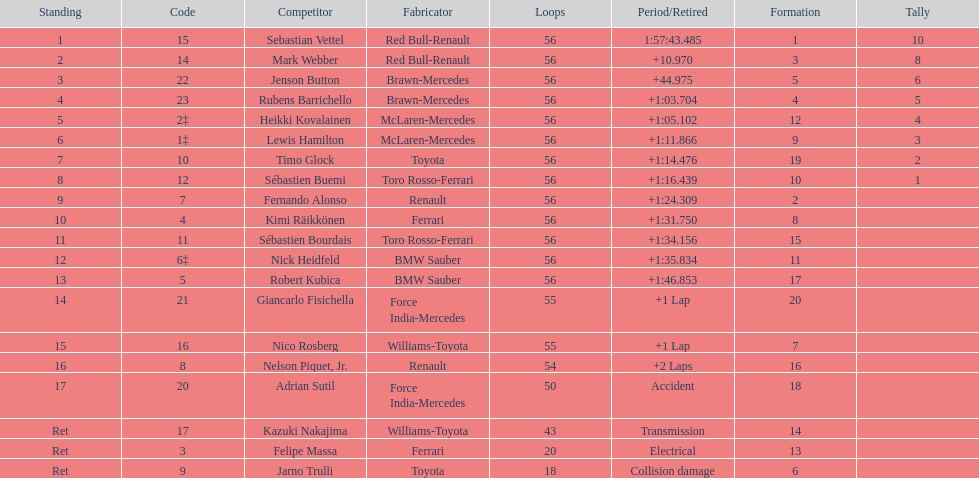What is the total number of drivers on the list? 20. 